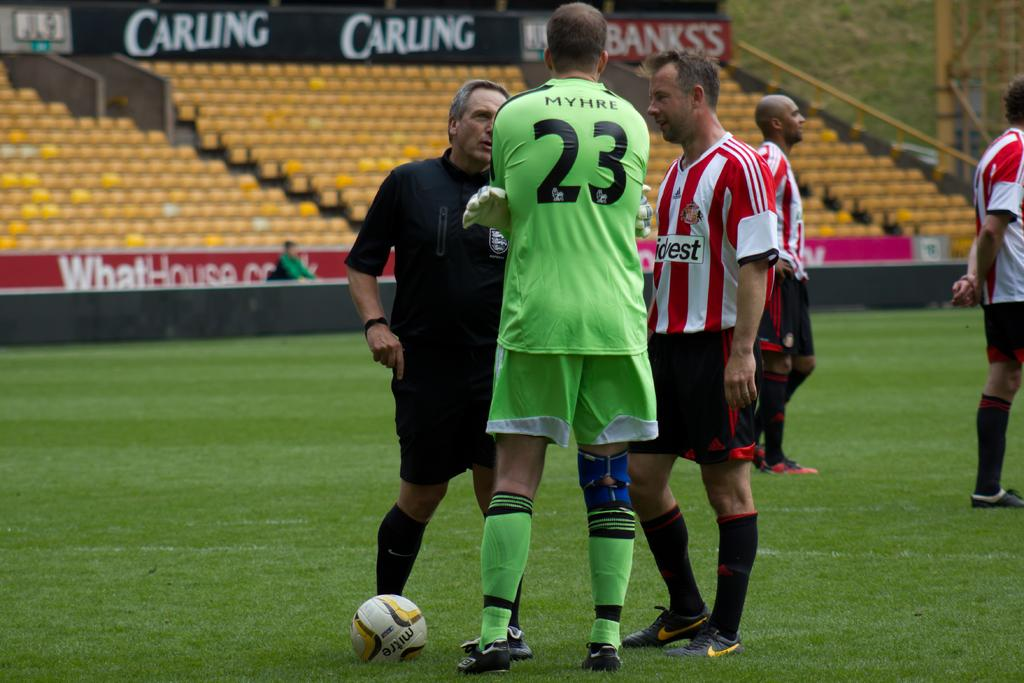Provide a one-sentence caption for the provided image. Soccer player number 23 speaks to his coach and the referee on a field sponsored by Carling. 